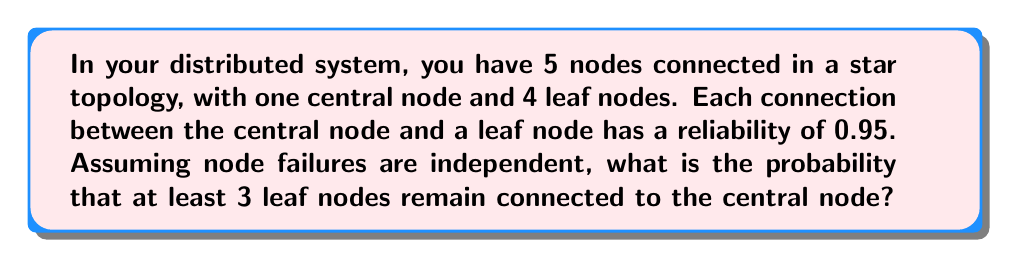Can you solve this math problem? Let's approach this step-by-step:

1) First, we need to understand what the question is asking. We want the probability of 3 or 4 leaf nodes remaining connected.

2) The probability of a single connection working is 0.95. Therefore, the probability of a connection failing is 1 - 0.95 = 0.05.

3) We can use the binomial probability formula to solve this. The probability of exactly k successes in n trials is:

   $$P(X = k) = \binom{n}{k} p^k (1-p)^{n-k}$$

   where n is the number of trials, k is the number of successes, p is the probability of success on each trial.

4) In our case, n = 4 (total leaf nodes), p = 0.95 (probability of a connection working), and we want the probability of k ≥ 3.

5) We need to calculate P(X = 3) + P(X = 4):

   $$P(X \geq 3) = \binom{4}{3} 0.95^3 0.05^1 + \binom{4}{4} 0.95^4 0.05^0$$

6) Let's calculate each part:
   
   $$\binom{4}{3} 0.95^3 0.05^1 = 4 \times 0.857375 \times 0.05 = 0.171475$$
   
   $$\binom{4}{4} 0.95^4 0.05^0 = 1 \times 0.814506 \times 1 = 0.814506$$

7) Adding these together:

   $$0.171475 + 0.814506 = 0.985981$$

Therefore, the probability that at least 3 leaf nodes remain connected is approximately 0.985981 or 98.5981%.
Answer: 0.985981 